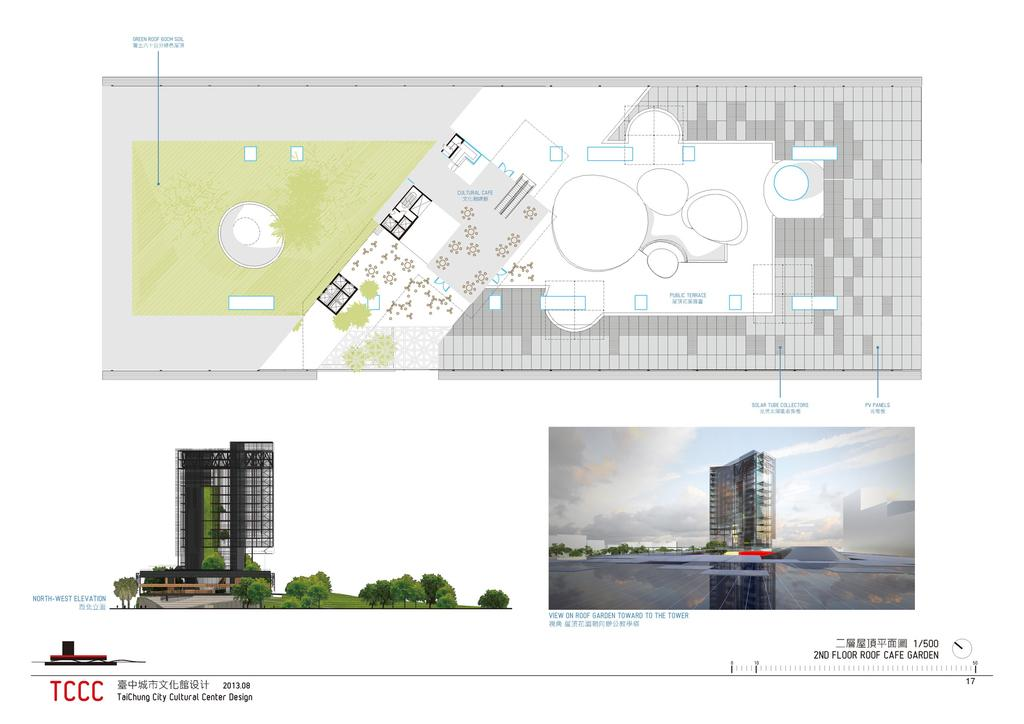What type of natural elements can be seen in the image? There are trees in the image. What type of man-made structures are visible in the image? There are buildings in the image. What is written on the image? There is something written on the image. What part of the natural environment is visible in the image? The sky is visible in the image. What type of artistic elements are present in the image? There are designs present in the image. What type of string is used to hold up the stocking in the image? There is no stocking or string present in the image. What type of riddle can be solved by looking at the image? There is no riddle present in the image. 